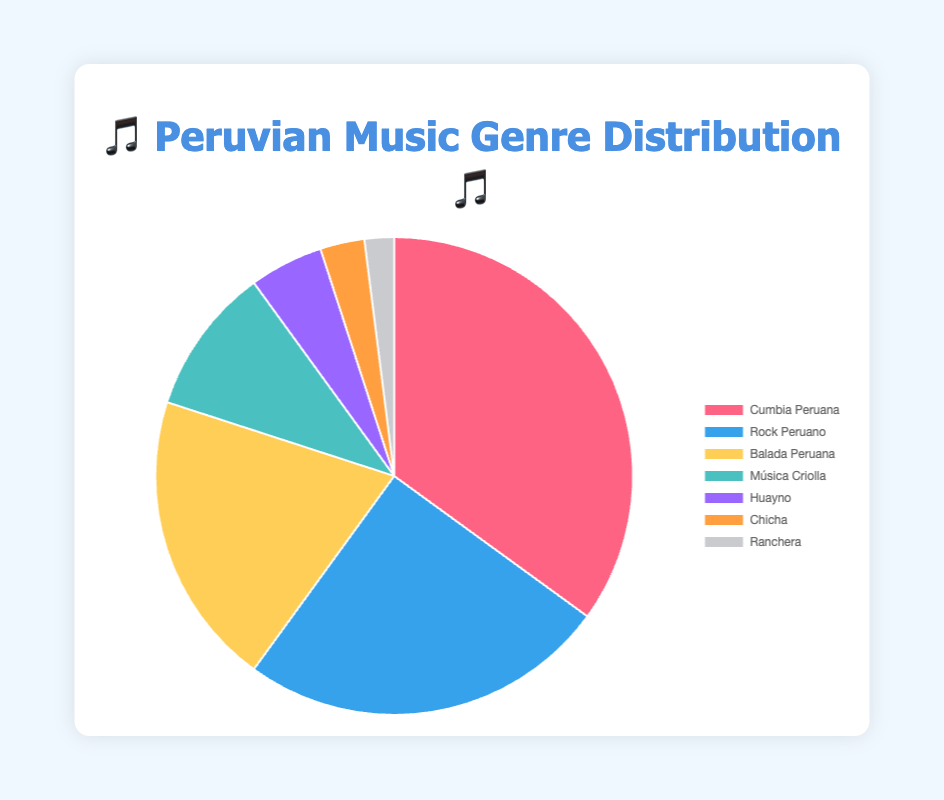What is the most popular Peruvian music genre on streaming platforms? The figure shows that "Cumbia Peruana" has the largest slice of the pie chart, representing 35% of the total.
Answer: Cumbia Peruana Which genre has the smallest share in the distribution? The smallest slice in the pie chart is dedicated to "Ranchera" with a 2% share.
Answer: Ranchera How much greater is the percentage of "Balada Peruana" compared to "Ranchera"? "Balada Peruana" has a 20% share while "Ranchera" has 2%, so the difference is 20% - 2% = 18%.
Answer: 18% What is the combined percentage of "Música Criolla" and "Huayno"? "Música Criolla" has a 10% share and "Huayno" has a 5% share. The combined percentage is 10% + 5% = 15%.
Answer: 15% Is "Rock Peruano" or "Balada Peruana" more popular? "Rock Peruano" has a 25% share while "Balada Peruana" has a 20% share. "Rock Peruano" is more popular by 5%.
Answer: Rock Peruano What is the total percentage for genres less popular than "Música Criolla"? Genres less popular than "Música Criolla" are "Huayno" (5%), "Chicha" (3%), and "Ranchera" (2%). The total is 5% + 3% + 2% = 10%.
Answer: 10% Which genre is represented by the 🎸 emoji and what is its percentage? The 🎸 emoji represents "Rock Peruano," which has a 25% share in the chart.
Answer: Rock Peruano, 25% Which emoji corresponds to the second least popular genre? The second least popular genre is "Chicha" with a 3% share, represented by the 🌴 emoji.
Answer: 🌴 How does the popularity of "Huayno" compare with "Chicha"? "Huayno" has a 5% share, while "Chicha" has a 3% share. "Huayno" is more popular by 2%.
Answer: Huayno What is the percentage difference between "Cumbia Peruana" and "Rock Peruano"? "Cumbia Peruana" has a 35% share and "Rock Peruano" has a 25% share. The difference is 35% - 25% = 10%.
Answer: 10% 